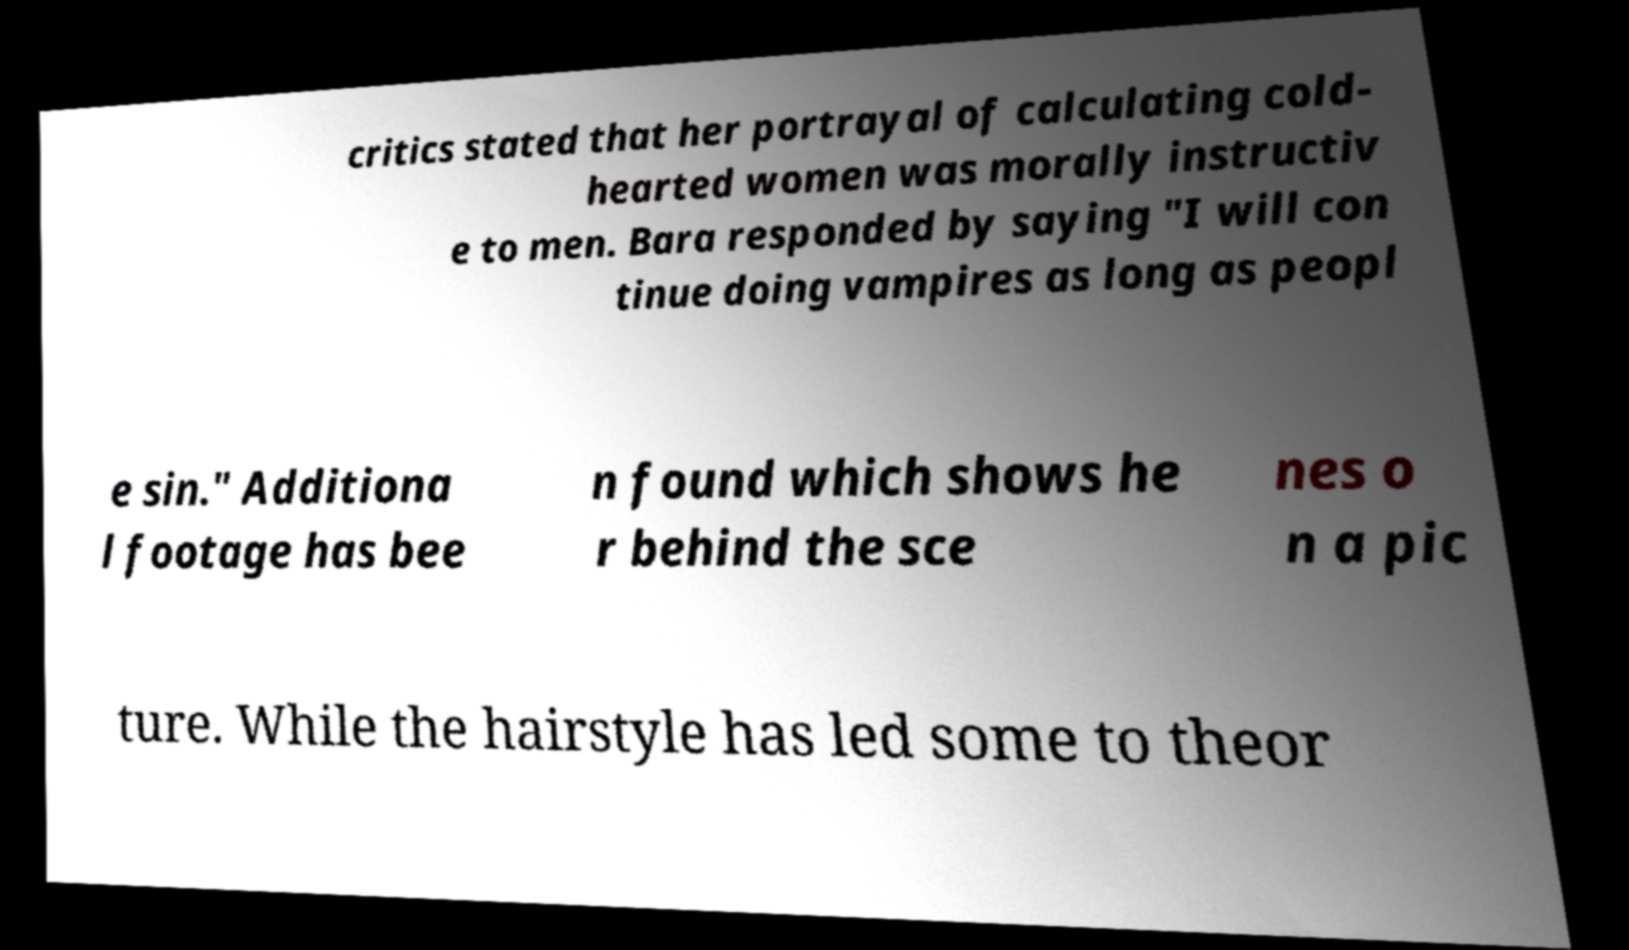Please read and relay the text visible in this image. What does it say? critics stated that her portrayal of calculating cold- hearted women was morally instructiv e to men. Bara responded by saying "I will con tinue doing vampires as long as peopl e sin." Additiona l footage has bee n found which shows he r behind the sce nes o n a pic ture. While the hairstyle has led some to theor 